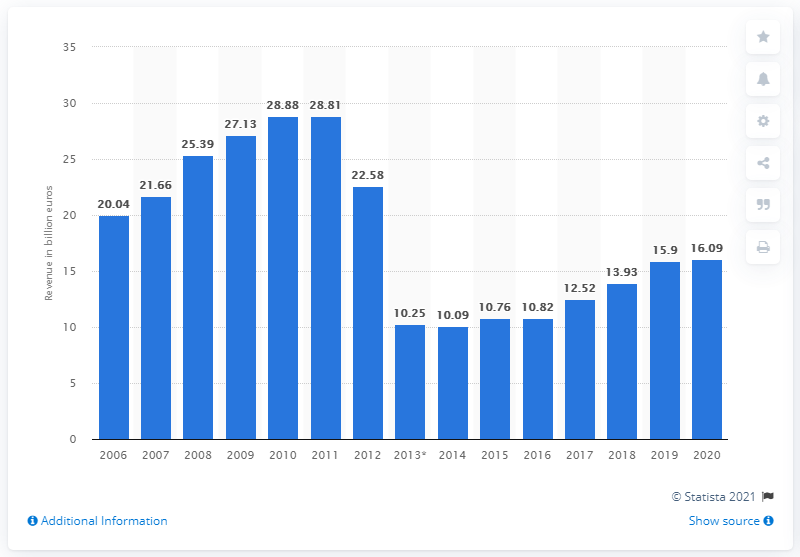Draw attention to some important aspects in this diagram. Vivendi's total revenue in 2020 was 16.09 billion dollars. Vivendi's revenue a year earlier was 15.9...million. 